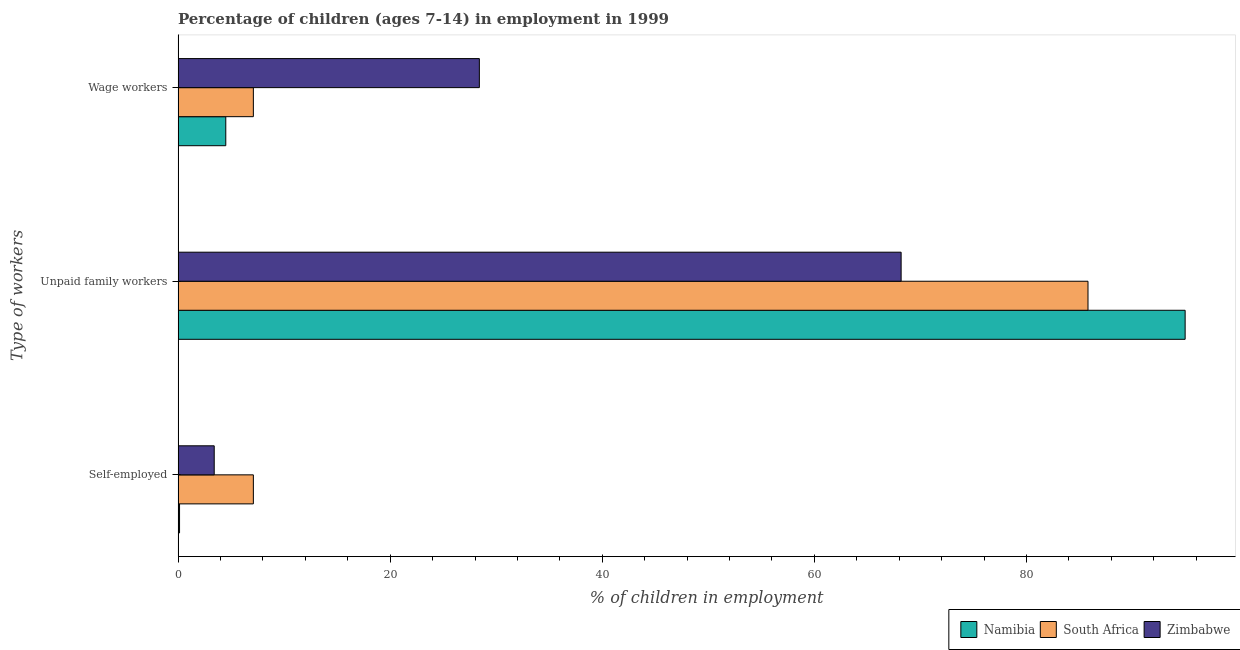How many groups of bars are there?
Your answer should be very brief. 3. Are the number of bars per tick equal to the number of legend labels?
Offer a terse response. Yes. What is the label of the 1st group of bars from the top?
Make the answer very short. Wage workers. What is the percentage of children employed as wage workers in Namibia?
Make the answer very short. 4.5. Across all countries, what is the maximum percentage of children employed as wage workers?
Your response must be concise. 28.41. Across all countries, what is the minimum percentage of self employed children?
Give a very brief answer. 0.14. In which country was the percentage of children employed as wage workers maximum?
Offer a terse response. Zimbabwe. In which country was the percentage of self employed children minimum?
Make the answer very short. Namibia. What is the total percentage of children employed as wage workers in the graph?
Your answer should be compact. 40.01. What is the difference between the percentage of children employed as wage workers in Zimbabwe and that in South Africa?
Your answer should be compact. 21.31. What is the difference between the percentage of self employed children in Namibia and the percentage of children employed as unpaid family workers in Zimbabwe?
Keep it short and to the point. -68.04. What is the average percentage of self employed children per country?
Offer a very short reply. 3.55. In how many countries, is the percentage of self employed children greater than 4 %?
Offer a terse response. 1. What is the ratio of the percentage of children employed as wage workers in Zimbabwe to that in Namibia?
Offer a very short reply. 6.31. What is the difference between the highest and the second highest percentage of children employed as wage workers?
Make the answer very short. 21.31. What is the difference between the highest and the lowest percentage of children employed as unpaid family workers?
Your response must be concise. 26.78. In how many countries, is the percentage of children employed as wage workers greater than the average percentage of children employed as wage workers taken over all countries?
Offer a terse response. 1. What does the 2nd bar from the top in Self-employed represents?
Give a very brief answer. South Africa. What does the 2nd bar from the bottom in Self-employed represents?
Your answer should be very brief. South Africa. How many bars are there?
Your answer should be very brief. 9. How many countries are there in the graph?
Ensure brevity in your answer.  3. Are the values on the major ticks of X-axis written in scientific E-notation?
Make the answer very short. No. Does the graph contain any zero values?
Keep it short and to the point. No. What is the title of the graph?
Provide a succinct answer. Percentage of children (ages 7-14) in employment in 1999. What is the label or title of the X-axis?
Your response must be concise. % of children in employment. What is the label or title of the Y-axis?
Offer a terse response. Type of workers. What is the % of children in employment of Namibia in Self-employed?
Give a very brief answer. 0.14. What is the % of children in employment of Zimbabwe in Self-employed?
Offer a terse response. 3.41. What is the % of children in employment of Namibia in Unpaid family workers?
Your answer should be very brief. 94.96. What is the % of children in employment of South Africa in Unpaid family workers?
Your answer should be very brief. 85.8. What is the % of children in employment of Zimbabwe in Unpaid family workers?
Make the answer very short. 68.18. What is the % of children in employment in Namibia in Wage workers?
Offer a terse response. 4.5. What is the % of children in employment of Zimbabwe in Wage workers?
Ensure brevity in your answer.  28.41. Across all Type of workers, what is the maximum % of children in employment in Namibia?
Provide a short and direct response. 94.96. Across all Type of workers, what is the maximum % of children in employment of South Africa?
Ensure brevity in your answer.  85.8. Across all Type of workers, what is the maximum % of children in employment in Zimbabwe?
Provide a short and direct response. 68.18. Across all Type of workers, what is the minimum % of children in employment of Namibia?
Your response must be concise. 0.14. Across all Type of workers, what is the minimum % of children in employment of South Africa?
Your answer should be compact. 7.1. Across all Type of workers, what is the minimum % of children in employment in Zimbabwe?
Make the answer very short. 3.41. What is the total % of children in employment in Namibia in the graph?
Your answer should be compact. 99.6. What is the total % of children in employment of South Africa in the graph?
Offer a terse response. 100. What is the total % of children in employment of Zimbabwe in the graph?
Provide a succinct answer. 100. What is the difference between the % of children in employment in Namibia in Self-employed and that in Unpaid family workers?
Your response must be concise. -94.82. What is the difference between the % of children in employment of South Africa in Self-employed and that in Unpaid family workers?
Offer a very short reply. -78.7. What is the difference between the % of children in employment of Zimbabwe in Self-employed and that in Unpaid family workers?
Offer a very short reply. -64.77. What is the difference between the % of children in employment of Namibia in Self-employed and that in Wage workers?
Keep it short and to the point. -4.36. What is the difference between the % of children in employment of Zimbabwe in Self-employed and that in Wage workers?
Provide a short and direct response. -25. What is the difference between the % of children in employment of Namibia in Unpaid family workers and that in Wage workers?
Your response must be concise. 90.46. What is the difference between the % of children in employment of South Africa in Unpaid family workers and that in Wage workers?
Your answer should be compact. 78.7. What is the difference between the % of children in employment in Zimbabwe in Unpaid family workers and that in Wage workers?
Your answer should be very brief. 39.77. What is the difference between the % of children in employment in Namibia in Self-employed and the % of children in employment in South Africa in Unpaid family workers?
Ensure brevity in your answer.  -85.66. What is the difference between the % of children in employment of Namibia in Self-employed and the % of children in employment of Zimbabwe in Unpaid family workers?
Your answer should be compact. -68.04. What is the difference between the % of children in employment of South Africa in Self-employed and the % of children in employment of Zimbabwe in Unpaid family workers?
Keep it short and to the point. -61.08. What is the difference between the % of children in employment in Namibia in Self-employed and the % of children in employment in South Africa in Wage workers?
Make the answer very short. -6.96. What is the difference between the % of children in employment of Namibia in Self-employed and the % of children in employment of Zimbabwe in Wage workers?
Your response must be concise. -28.27. What is the difference between the % of children in employment of South Africa in Self-employed and the % of children in employment of Zimbabwe in Wage workers?
Your answer should be compact. -21.31. What is the difference between the % of children in employment in Namibia in Unpaid family workers and the % of children in employment in South Africa in Wage workers?
Make the answer very short. 87.86. What is the difference between the % of children in employment of Namibia in Unpaid family workers and the % of children in employment of Zimbabwe in Wage workers?
Your response must be concise. 66.55. What is the difference between the % of children in employment of South Africa in Unpaid family workers and the % of children in employment of Zimbabwe in Wage workers?
Ensure brevity in your answer.  57.39. What is the average % of children in employment of Namibia per Type of workers?
Make the answer very short. 33.2. What is the average % of children in employment of South Africa per Type of workers?
Your response must be concise. 33.33. What is the average % of children in employment of Zimbabwe per Type of workers?
Offer a terse response. 33.33. What is the difference between the % of children in employment in Namibia and % of children in employment in South Africa in Self-employed?
Keep it short and to the point. -6.96. What is the difference between the % of children in employment of Namibia and % of children in employment of Zimbabwe in Self-employed?
Your answer should be compact. -3.27. What is the difference between the % of children in employment of South Africa and % of children in employment of Zimbabwe in Self-employed?
Offer a very short reply. 3.69. What is the difference between the % of children in employment of Namibia and % of children in employment of South Africa in Unpaid family workers?
Provide a succinct answer. 9.16. What is the difference between the % of children in employment in Namibia and % of children in employment in Zimbabwe in Unpaid family workers?
Offer a terse response. 26.78. What is the difference between the % of children in employment of South Africa and % of children in employment of Zimbabwe in Unpaid family workers?
Provide a short and direct response. 17.62. What is the difference between the % of children in employment of Namibia and % of children in employment of South Africa in Wage workers?
Provide a short and direct response. -2.6. What is the difference between the % of children in employment in Namibia and % of children in employment in Zimbabwe in Wage workers?
Keep it short and to the point. -23.91. What is the difference between the % of children in employment in South Africa and % of children in employment in Zimbabwe in Wage workers?
Keep it short and to the point. -21.31. What is the ratio of the % of children in employment of Namibia in Self-employed to that in Unpaid family workers?
Your answer should be compact. 0. What is the ratio of the % of children in employment in South Africa in Self-employed to that in Unpaid family workers?
Make the answer very short. 0.08. What is the ratio of the % of children in employment in Zimbabwe in Self-employed to that in Unpaid family workers?
Your response must be concise. 0.05. What is the ratio of the % of children in employment in Namibia in Self-employed to that in Wage workers?
Provide a short and direct response. 0.03. What is the ratio of the % of children in employment in Zimbabwe in Self-employed to that in Wage workers?
Give a very brief answer. 0.12. What is the ratio of the % of children in employment of Namibia in Unpaid family workers to that in Wage workers?
Make the answer very short. 21.1. What is the ratio of the % of children in employment in South Africa in Unpaid family workers to that in Wage workers?
Provide a succinct answer. 12.08. What is the ratio of the % of children in employment in Zimbabwe in Unpaid family workers to that in Wage workers?
Your answer should be very brief. 2.4. What is the difference between the highest and the second highest % of children in employment of Namibia?
Provide a short and direct response. 90.46. What is the difference between the highest and the second highest % of children in employment of South Africa?
Ensure brevity in your answer.  78.7. What is the difference between the highest and the second highest % of children in employment in Zimbabwe?
Keep it short and to the point. 39.77. What is the difference between the highest and the lowest % of children in employment of Namibia?
Ensure brevity in your answer.  94.82. What is the difference between the highest and the lowest % of children in employment in South Africa?
Make the answer very short. 78.7. What is the difference between the highest and the lowest % of children in employment of Zimbabwe?
Give a very brief answer. 64.77. 